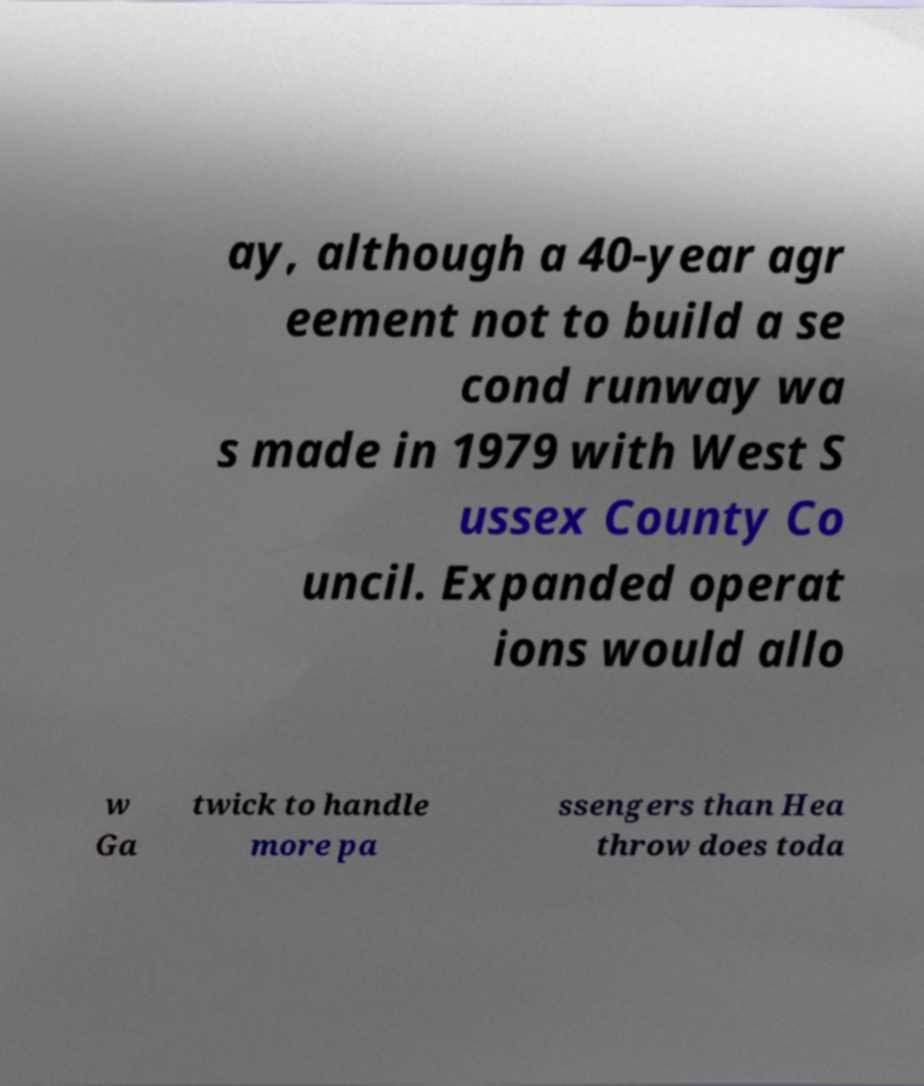Can you accurately transcribe the text from the provided image for me? ay, although a 40-year agr eement not to build a se cond runway wa s made in 1979 with West S ussex County Co uncil. Expanded operat ions would allo w Ga twick to handle more pa ssengers than Hea throw does toda 